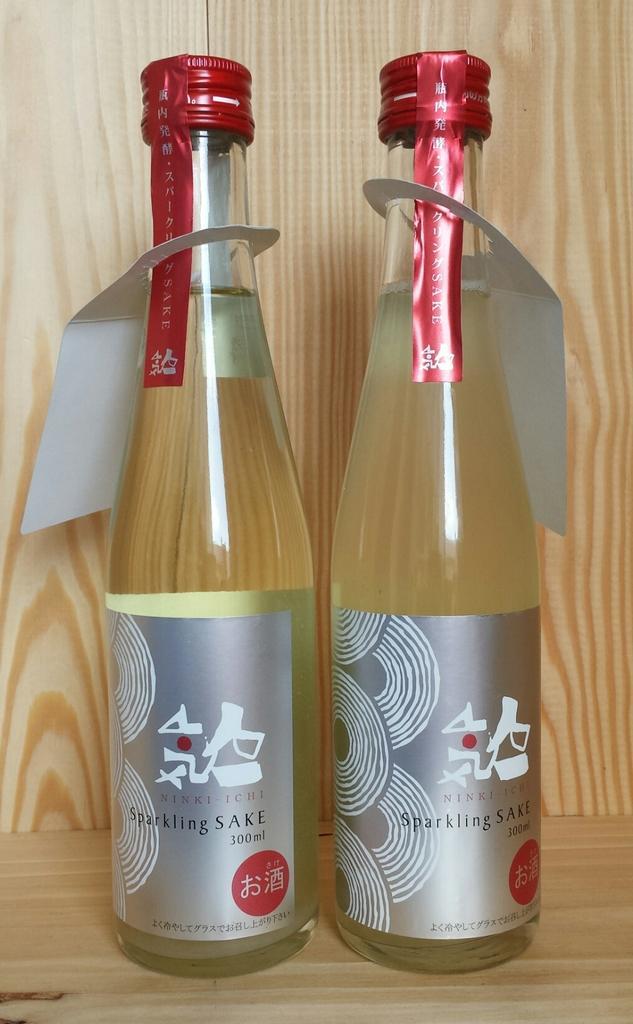Can you describe this image briefly? In this image i can see there is two glass bottles. 